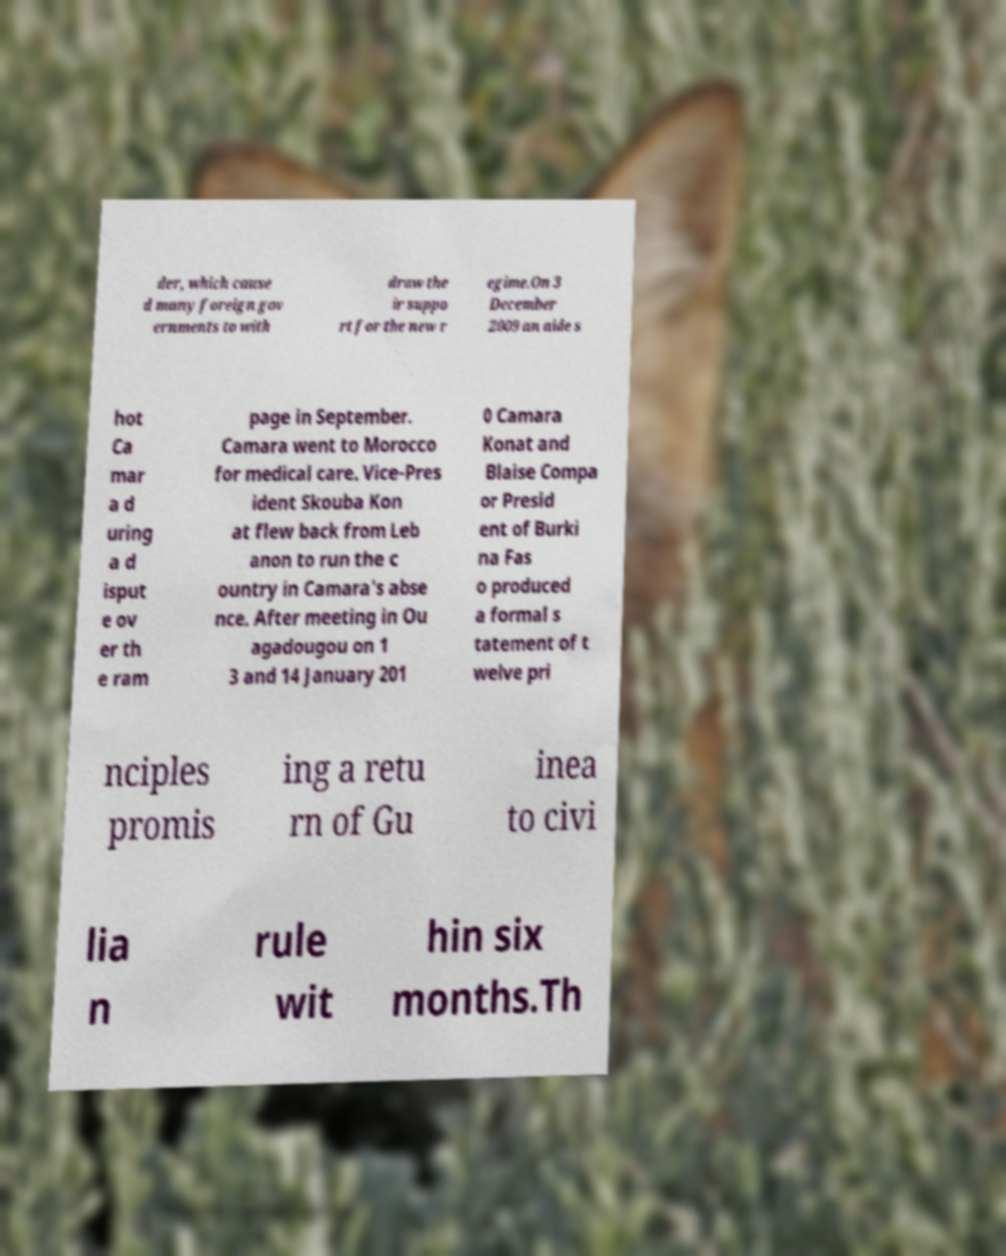Can you accurately transcribe the text from the provided image for me? der, which cause d many foreign gov ernments to with draw the ir suppo rt for the new r egime.On 3 December 2009 an aide s hot Ca mar a d uring a d isput e ov er th e ram page in September. Camara went to Morocco for medical care. Vice-Pres ident Skouba Kon at flew back from Leb anon to run the c ountry in Camara's abse nce. After meeting in Ou agadougou on 1 3 and 14 January 201 0 Camara Konat and Blaise Compa or Presid ent of Burki na Fas o produced a formal s tatement of t welve pri nciples promis ing a retu rn of Gu inea to civi lia n rule wit hin six months.Th 